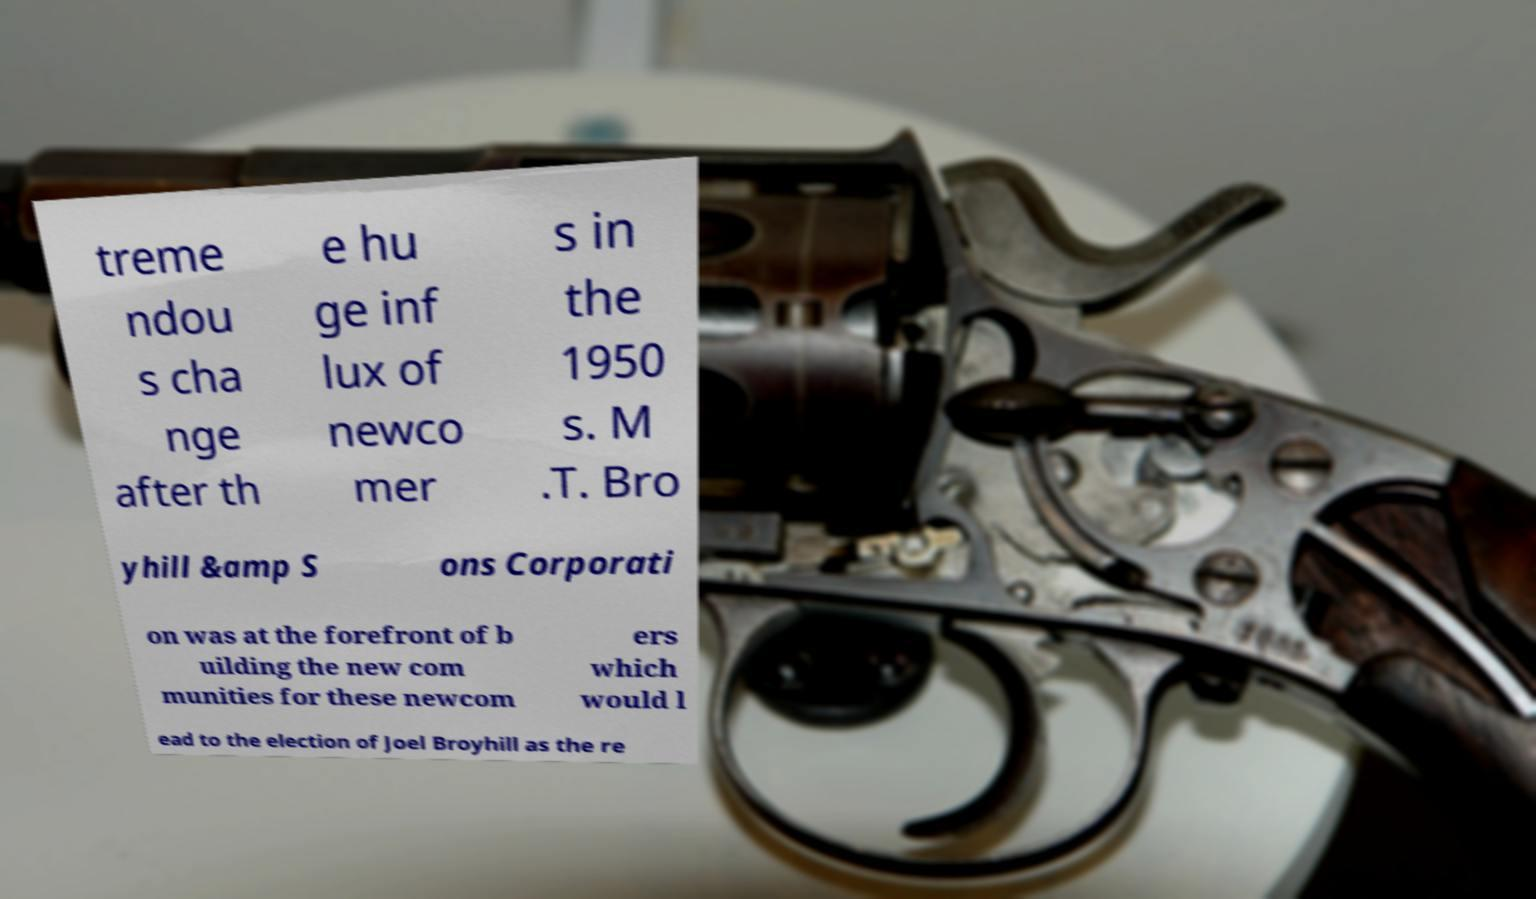Could you assist in decoding the text presented in this image and type it out clearly? treme ndou s cha nge after th e hu ge inf lux of newco mer s in the 1950 s. M .T. Bro yhill &amp S ons Corporati on was at the forefront of b uilding the new com munities for these newcom ers which would l ead to the election of Joel Broyhill as the re 